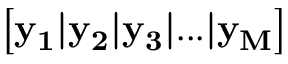<formula> <loc_0><loc_0><loc_500><loc_500>\left [ y _ { 1 } | y _ { 2 } | y _ { 3 } | \dots | y _ { M } \right ]</formula> 